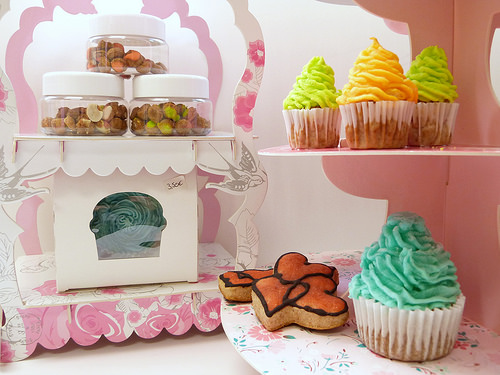<image>
Can you confirm if the cookie is on the shelf? No. The cookie is not positioned on the shelf. They may be near each other, but the cookie is not supported by or resting on top of the shelf. Is the bottle to the left of the cupcake? Yes. From this viewpoint, the bottle is positioned to the left side relative to the cupcake. Is the cupcake under the cupcake? Yes. The cupcake is positioned underneath the cupcake, with the cupcake above it in the vertical space. Where is the cupcake in relation to the sugar cookie? Is it next to the sugar cookie? No. The cupcake is not positioned next to the sugar cookie. They are located in different areas of the scene. Where is the cupcake in relation to the cookie? Is it in front of the cookie? No. The cupcake is not in front of the cookie. The spatial positioning shows a different relationship between these objects. 